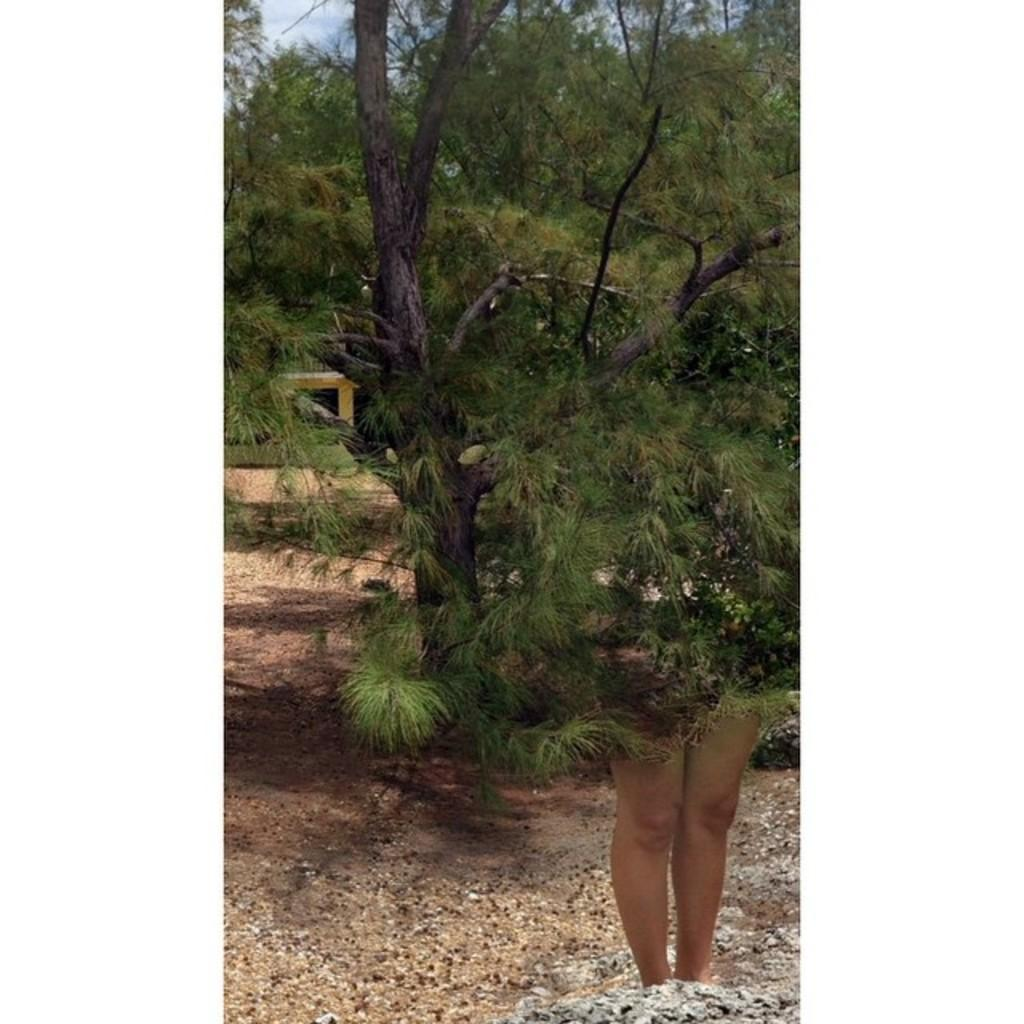What can be seen at the bottom of the image? There are legs of a person in the image. What type of natural elements are present in the image? There are trees in the image. What is visible in the background of the image? The sky is visible in the background of the image. What type of quartz can be seen in the image? There is no quartz present in the image. How does the twig contribute to the person's movement in the image? There is no twig present in the image, so it cannot contribute to the person's movement. 